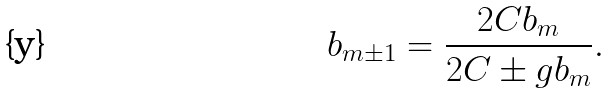Convert formula to latex. <formula><loc_0><loc_0><loc_500><loc_500>b _ { m \pm 1 } = \frac { 2 C b _ { m } } { 2 C \pm g b _ { m } } .</formula> 